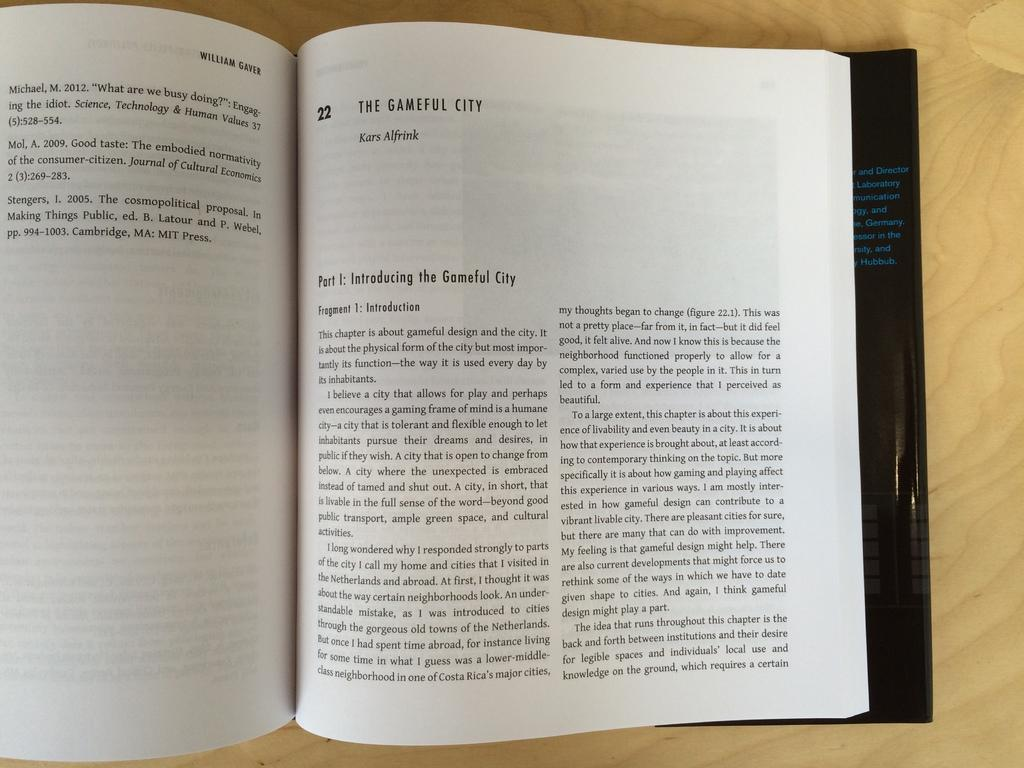<image>
Describe the image concisely. open book, the gameful city by william gaver 